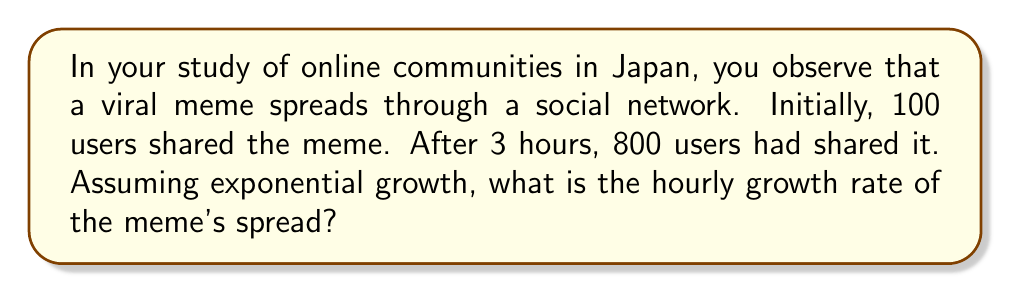Could you help me with this problem? Let's approach this step-by-step using the exponential growth formula:

1) The exponential growth formula is:
   $$A = P(1 + r)^t$$
   Where:
   $A$ = Final amount
   $P$ = Initial amount
   $r$ = Growth rate (as a decimal)
   $t$ = Time period

2) We know:
   $P = 100$ (initial users)
   $A = 800$ (final users)
   $t = 3$ (hours)

3) Let's plug these into our formula:
   $$800 = 100(1 + r)^3$$

4) Divide both sides by 100:
   $$8 = (1 + r)^3$$

5) Take the cube root of both sides:
   $$\sqrt[3]{8} = 1 + r$$

6) Simplify:
   $$2 = 1 + r$$

7) Subtract 1 from both sides:
   $$r = 1$$

8) Convert to a percentage:
   $$r = 100\%$$

This means the meme is growing by 100% (doubling) every hour.
Answer: 100% per hour 